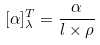<formula> <loc_0><loc_0><loc_500><loc_500>[ \alpha ] _ { \lambda } ^ { T } = \frac { \alpha } { l \times \rho }</formula> 